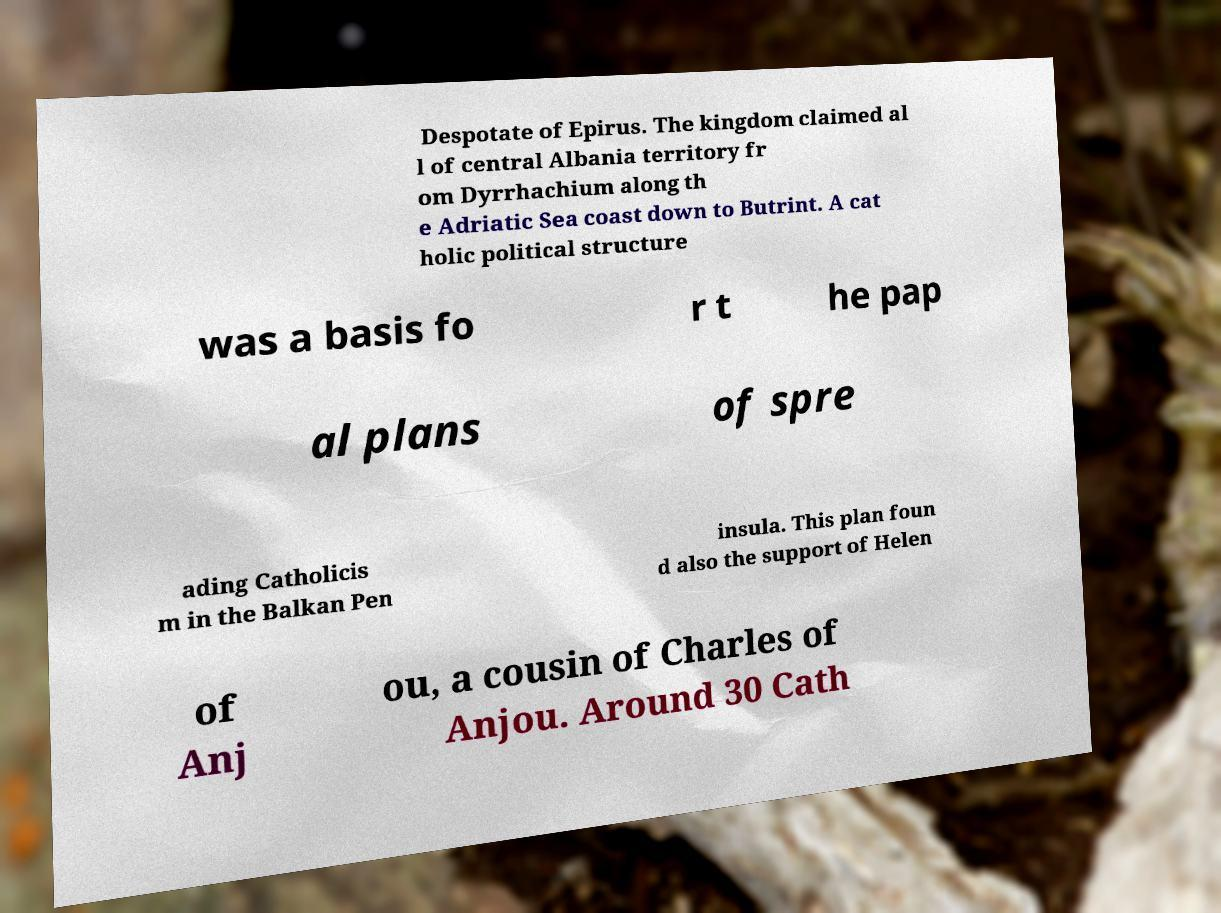Could you assist in decoding the text presented in this image and type it out clearly? Despotate of Epirus. The kingdom claimed al l of central Albania territory fr om Dyrrhachium along th e Adriatic Sea coast down to Butrint. A cat holic political structure was a basis fo r t he pap al plans of spre ading Catholicis m in the Balkan Pen insula. This plan foun d also the support of Helen of Anj ou, a cousin of Charles of Anjou. Around 30 Cath 